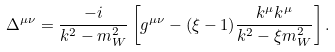Convert formula to latex. <formula><loc_0><loc_0><loc_500><loc_500>\Delta ^ { \mu \nu } = \frac { - i } { k ^ { 2 } - m ^ { 2 } _ { W } } \left [ g ^ { \mu \nu } - ( \xi - 1 ) \frac { k ^ { \mu } k ^ { \mu } } { k ^ { 2 } - \xi m ^ { 2 } _ { W } } \right ] .</formula> 